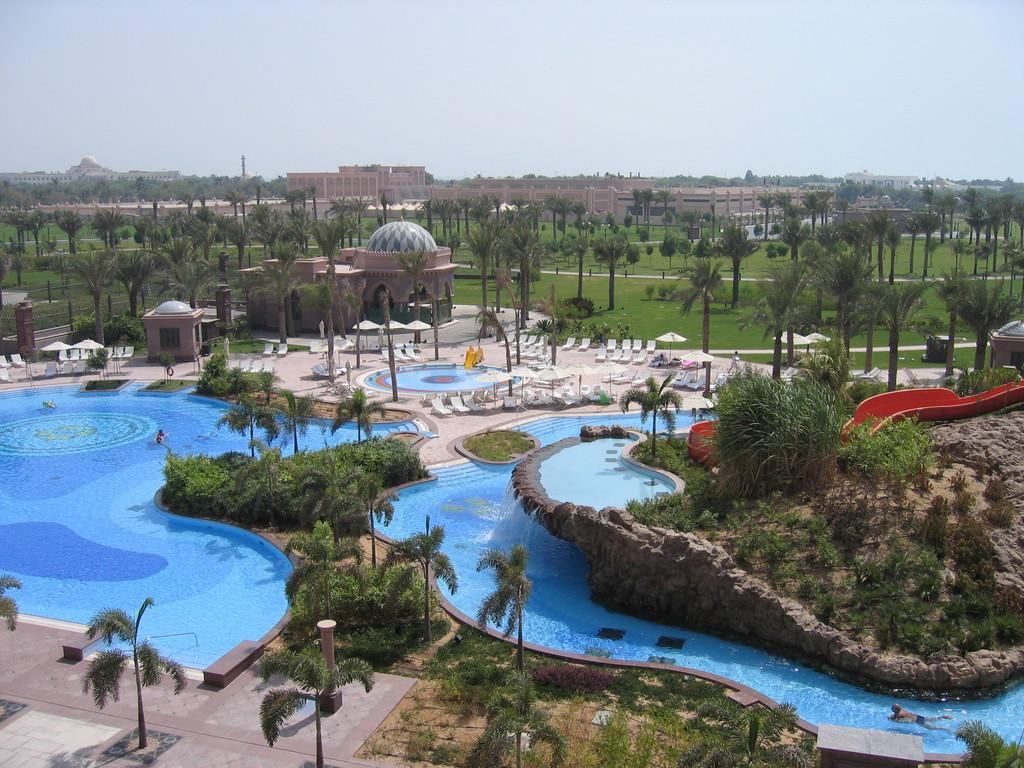What type of recreational facility is depicted in the image? The image shows swimming pools and slides, which are common features of water parks or recreational facilities. What type of seating is available in the image? There are chairs in the image for people to sit on. What type of shade is provided in the image? There are umbrellas in the image to provide shade. What type of vegetation is present in the image? There are trees in the image. What type of structures are visible in the image? There are buildings in the image. What can be seen in the background of the image? The sky is visible in the background of the image. Can you tell me how many mittens are being used by the kittens in the image? There are no mittens or kittens present in the image. What hobbies are the people in the image engaged in? The image does not show people engaged in specific hobbies; it primarily features swimming pools, slides, chairs, umbrellas, trees, buildings, and the sky. 